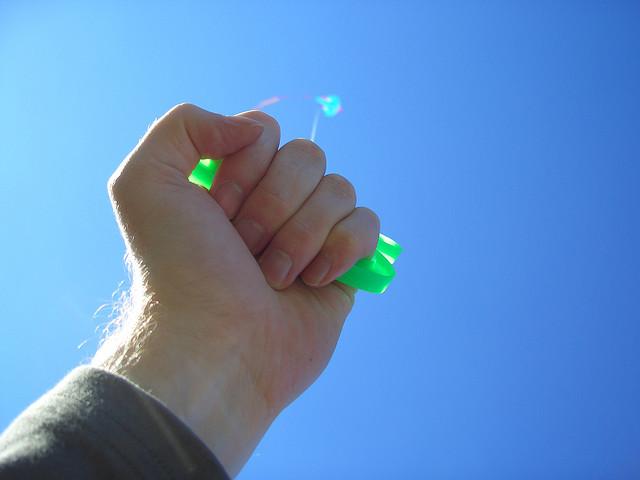What color is in the person's hands?
Concise answer only. Green. Is it cloudy?
Quick response, please. No. What is in the person's hand?
Answer briefly. Kite. 